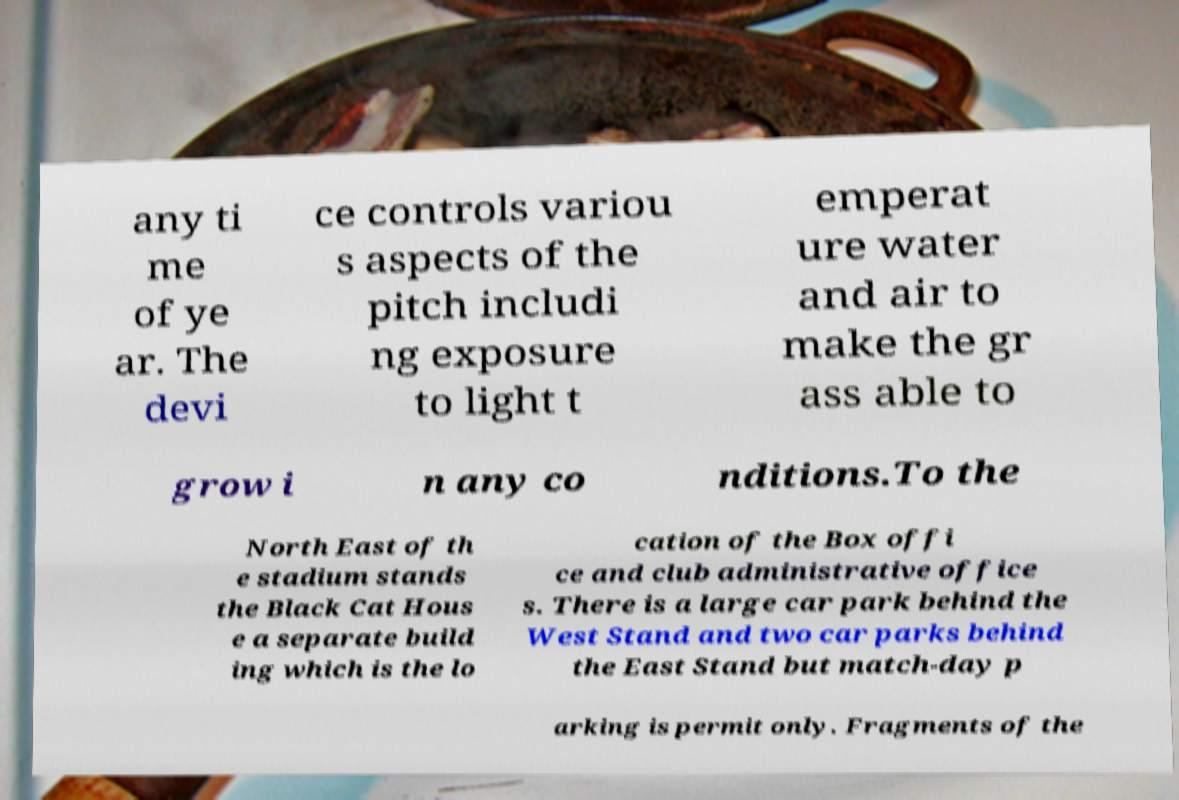Can you read and provide the text displayed in the image?This photo seems to have some interesting text. Can you extract and type it out for me? any ti me of ye ar. The devi ce controls variou s aspects of the pitch includi ng exposure to light t emperat ure water and air to make the gr ass able to grow i n any co nditions.To the North East of th e stadium stands the Black Cat Hous e a separate build ing which is the lo cation of the Box offi ce and club administrative office s. There is a large car park behind the West Stand and two car parks behind the East Stand but match-day p arking is permit only. Fragments of the 